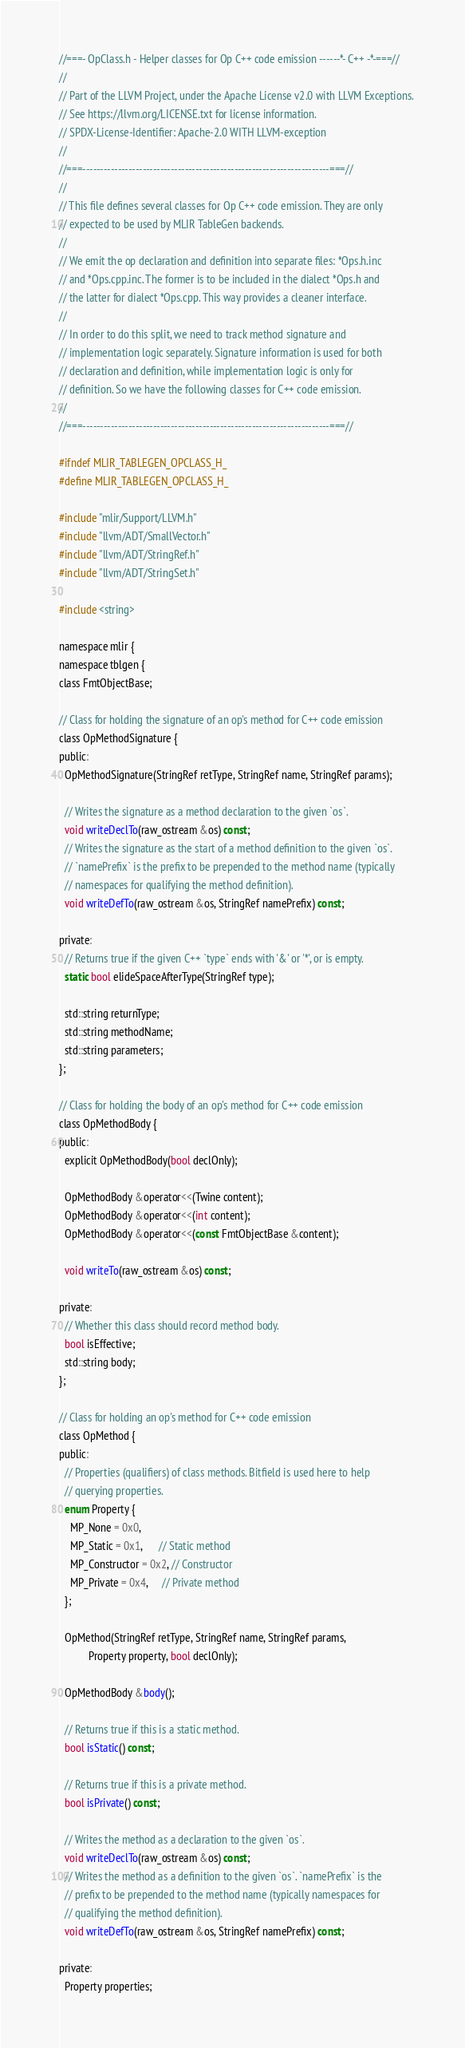Convert code to text. <code><loc_0><loc_0><loc_500><loc_500><_C_>//===- OpClass.h - Helper classes for Op C++ code emission ------*- C++ -*-===//
//
// Part of the LLVM Project, under the Apache License v2.0 with LLVM Exceptions.
// See https://llvm.org/LICENSE.txt for license information.
// SPDX-License-Identifier: Apache-2.0 WITH LLVM-exception
//
//===----------------------------------------------------------------------===//
//
// This file defines several classes for Op C++ code emission. They are only
// expected to be used by MLIR TableGen backends.
//
// We emit the op declaration and definition into separate files: *Ops.h.inc
// and *Ops.cpp.inc. The former is to be included in the dialect *Ops.h and
// the latter for dialect *Ops.cpp. This way provides a cleaner interface.
//
// In order to do this split, we need to track method signature and
// implementation logic separately. Signature information is used for both
// declaration and definition, while implementation logic is only for
// definition. So we have the following classes for C++ code emission.
//
//===----------------------------------------------------------------------===//

#ifndef MLIR_TABLEGEN_OPCLASS_H_
#define MLIR_TABLEGEN_OPCLASS_H_

#include "mlir/Support/LLVM.h"
#include "llvm/ADT/SmallVector.h"
#include "llvm/ADT/StringRef.h"
#include "llvm/ADT/StringSet.h"

#include <string>

namespace mlir {
namespace tblgen {
class FmtObjectBase;

// Class for holding the signature of an op's method for C++ code emission
class OpMethodSignature {
public:
  OpMethodSignature(StringRef retType, StringRef name, StringRef params);

  // Writes the signature as a method declaration to the given `os`.
  void writeDeclTo(raw_ostream &os) const;
  // Writes the signature as the start of a method definition to the given `os`.
  // `namePrefix` is the prefix to be prepended to the method name (typically
  // namespaces for qualifying the method definition).
  void writeDefTo(raw_ostream &os, StringRef namePrefix) const;

private:
  // Returns true if the given C++ `type` ends with '&' or '*', or is empty.
  static bool elideSpaceAfterType(StringRef type);

  std::string returnType;
  std::string methodName;
  std::string parameters;
};

// Class for holding the body of an op's method for C++ code emission
class OpMethodBody {
public:
  explicit OpMethodBody(bool declOnly);

  OpMethodBody &operator<<(Twine content);
  OpMethodBody &operator<<(int content);
  OpMethodBody &operator<<(const FmtObjectBase &content);

  void writeTo(raw_ostream &os) const;

private:
  // Whether this class should record method body.
  bool isEffective;
  std::string body;
};

// Class for holding an op's method for C++ code emission
class OpMethod {
public:
  // Properties (qualifiers) of class methods. Bitfield is used here to help
  // querying properties.
  enum Property {
    MP_None = 0x0,
    MP_Static = 0x1,      // Static method
    MP_Constructor = 0x2, // Constructor
    MP_Private = 0x4,     // Private method
  };

  OpMethod(StringRef retType, StringRef name, StringRef params,
           Property property, bool declOnly);

  OpMethodBody &body();

  // Returns true if this is a static method.
  bool isStatic() const;

  // Returns true if this is a private method.
  bool isPrivate() const;

  // Writes the method as a declaration to the given `os`.
  void writeDeclTo(raw_ostream &os) const;
  // Writes the method as a definition to the given `os`. `namePrefix` is the
  // prefix to be prepended to the method name (typically namespaces for
  // qualifying the method definition).
  void writeDefTo(raw_ostream &os, StringRef namePrefix) const;

private:
  Property properties;</code> 